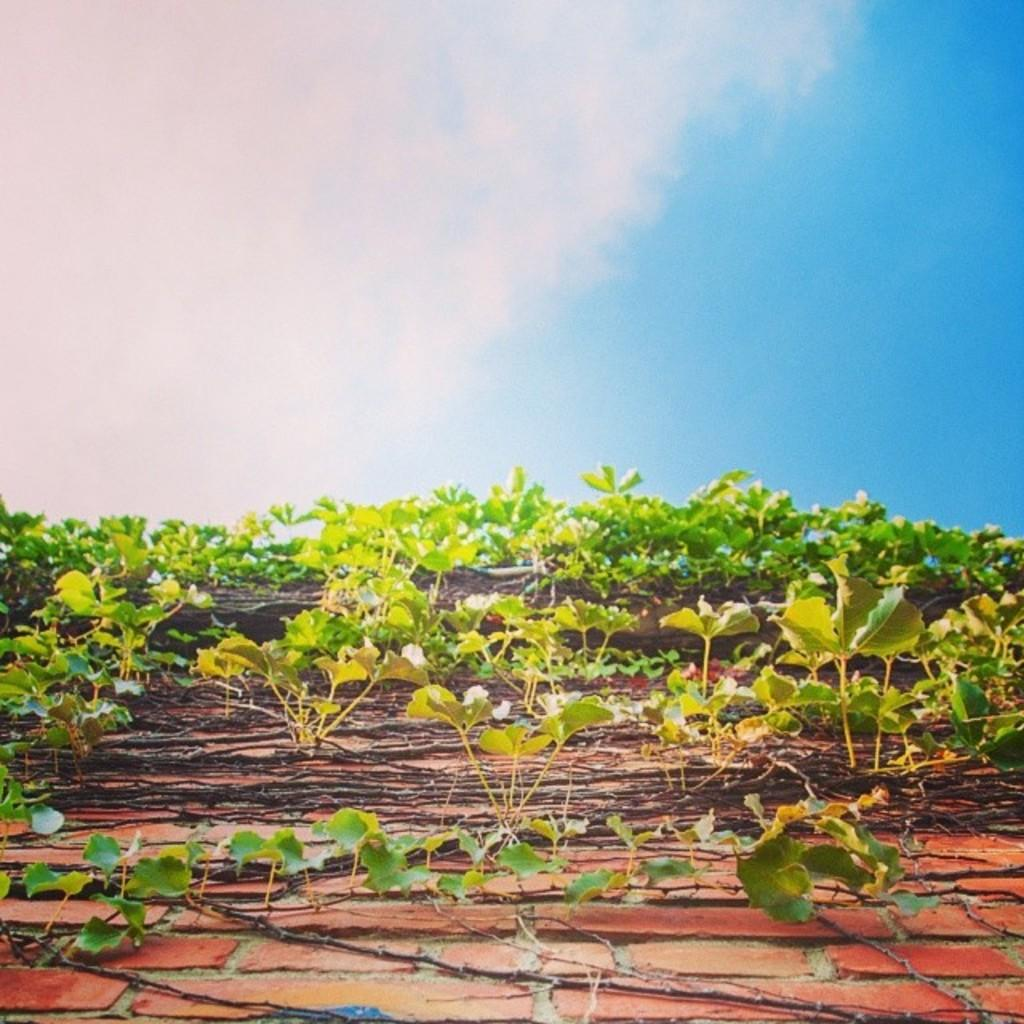What type of vegetation is growing on the wall in the image? There are creepers on the wall in the image. What can be seen in the sky in the image? Clouds are visible in the sky in the image. What type of jelly can be seen in the image? There is no jelly present in the image. What is the profit margin of the store in the image? There is no store present in the image, so it is not possible to determine the profit margin. 